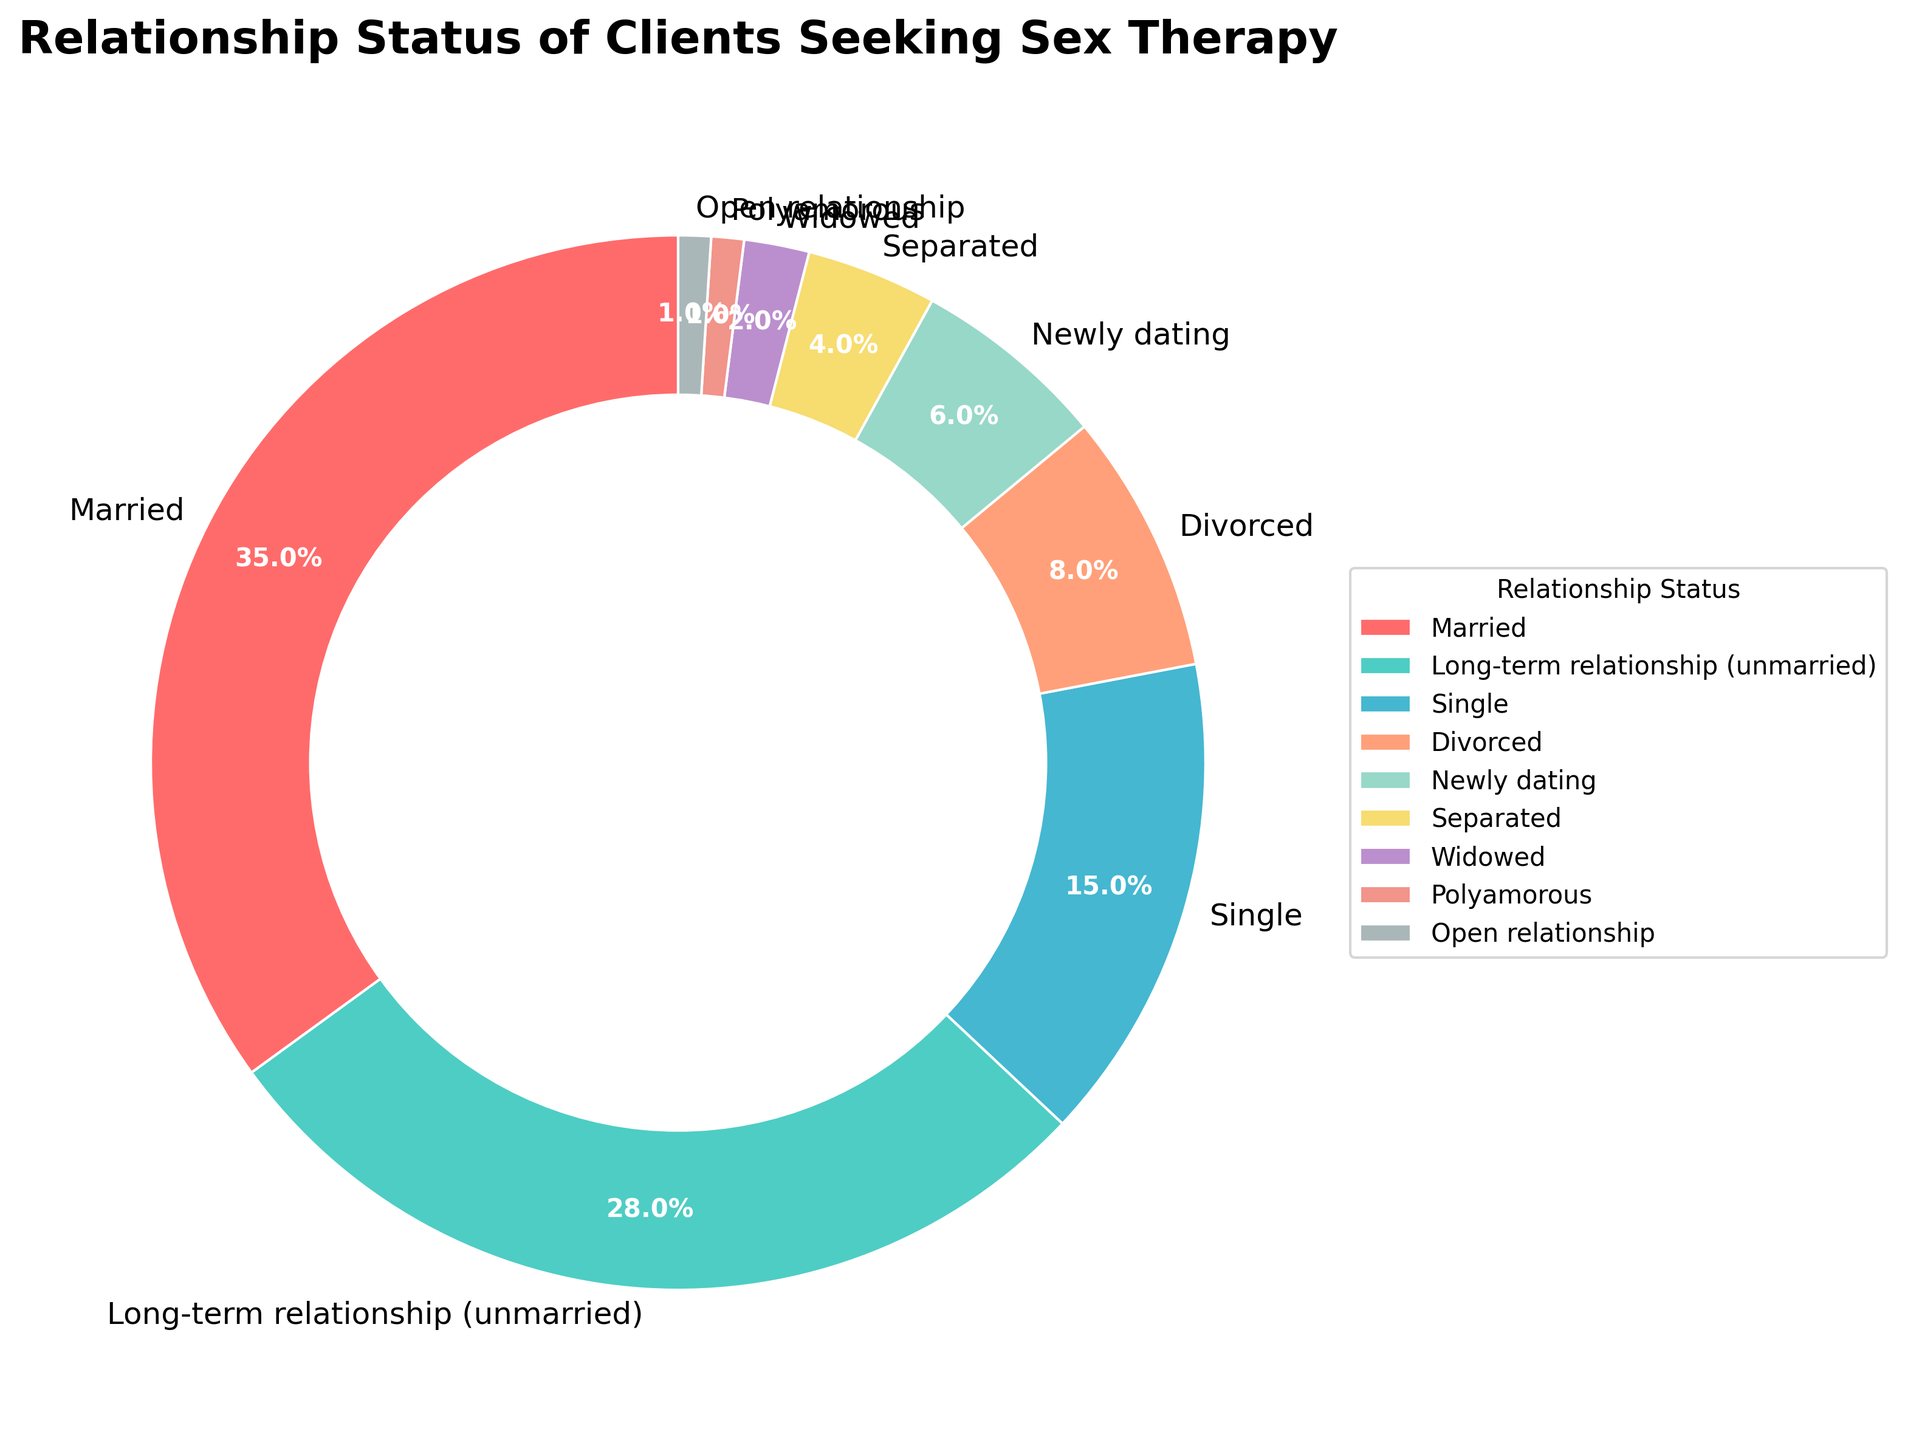What relationship status has the highest percentage of clients seeking sex therapy? The slice with the largest size and percentage annotation represents the relationship status with the highest percentage. From the pie chart, the "Married" category has the highest percentage of 35%.
Answer: Married (35%) Which two relationship status categories together account for more than 50% of clients? Add the percentages of the different categories until the sum exceeds 50%. The "Married" (35%) and "Long-term relationship (unmarried)" (28%) categories together account for 63%, which is more than 50%.
Answer: Married and Long-term relationship (unmarried) (63%) Compare the percentage of clients who are divorced to those who are separated. Which is higher and by how much? Check the percentage annotations for "Divorced" and "Separated" categories. Divorced has 8% while Separated has 4%. Subtract the smaller percentage from the larger one: 8% - 4% = 4%.
Answer: Divorced is higher by 4% What proportion of clients are in non-monogamous relationships (Polyamorous and Open relationship combined)? Add the percentages of the "Polyamorous" (1%) and "Open relationship" (1%) categories. The sum is 1% + 1% = 2%.
Answer: 2% How much higher is the percentage of single clients compared to those who are newly dating? Check the percentage annotations for "Single" and "Newly dating" categories. Single has 15% while Newly dating has 6%. Subtract the smaller percentage from the larger one: 15% - 6% = 9%.
Answer: 9% Which relationship status category has the smallest percentage and what is the percentage? Locate the smallest slice in the pie chart and its percentage annotation. The "Polyamorous" and "Open relationship" categories both have the smallest percentage of 1%.
Answer: Polyamorous and Open relationship (1%) If you combine the percentages of clients who are either divorced, separated, or widowed, what is the total percentage? Add the percentages of "Divorced" (8%), "Separated" (4%), and "Widowed" (2%). The sum is 8% + 4% + 2% = 14%.
Answer: 14% What is the combined percentage of clients who are in monogamous relationships (Married, Long-term relationship, Newly dating)? Add the percentages of "Married" (35%), "Long-term relationship (unmarried)" (28%), and "Newly dating" (6%). The sum is 35% + 28% + 6% = 69%.
Answer: 69% Compare and contrast the visual sizes of the "Married" and "Single" categories. Which one appears larger and by how much? Visually compare the slices of the "Married" and "Single" categories. The "Married" slice is significantly larger. Subtract the percentages: 35% - 15% = 20%.
Answer: Married is larger by 20% 